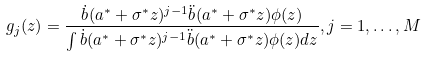<formula> <loc_0><loc_0><loc_500><loc_500>g _ { j } ( z ) = \frac { \dot { b } ( a ^ { \ast } + \sigma ^ { \ast } z ) ^ { j - 1 } \ddot { b } ( a ^ { \ast } + \sigma ^ { \ast } z ) \phi ( z ) } { \int \dot { b } ( a ^ { \ast } + \sigma ^ { \ast } z ) ^ { j - 1 } \ddot { b } ( a ^ { \ast } + \sigma ^ { \ast } z ) \phi ( z ) d z } , j = 1 , \dots , M</formula> 